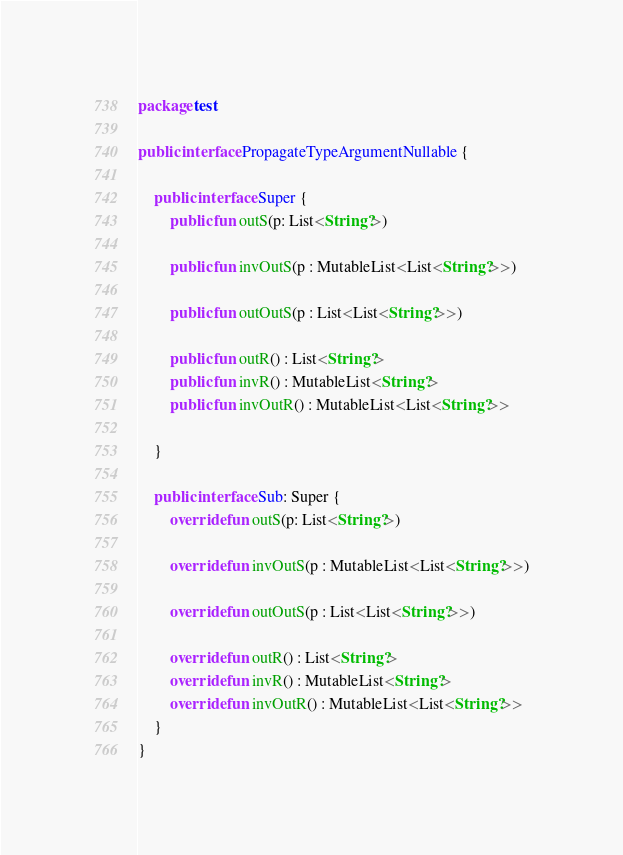Convert code to text. <code><loc_0><loc_0><loc_500><loc_500><_Kotlin_>package test

public interface PropagateTypeArgumentNullable {

    public interface Super {
        public fun outS(p: List<String?>)

        public fun invOutS(p : MutableList<List<String?>>)

        public fun outOutS(p : List<List<String?>>)

        public fun outR() : List<String?>
        public fun invR() : MutableList<String?>
        public fun invOutR() : MutableList<List<String?>>

    }

    public interface Sub: Super {
        override fun outS(p: List<String?>)

        override fun invOutS(p : MutableList<List<String?>>)

        override fun outOutS(p : List<List<String?>>)

        override fun outR() : List<String?>
        override fun invR() : MutableList<String?>
        override fun invOutR() : MutableList<List<String?>>
    }
}
</code> 